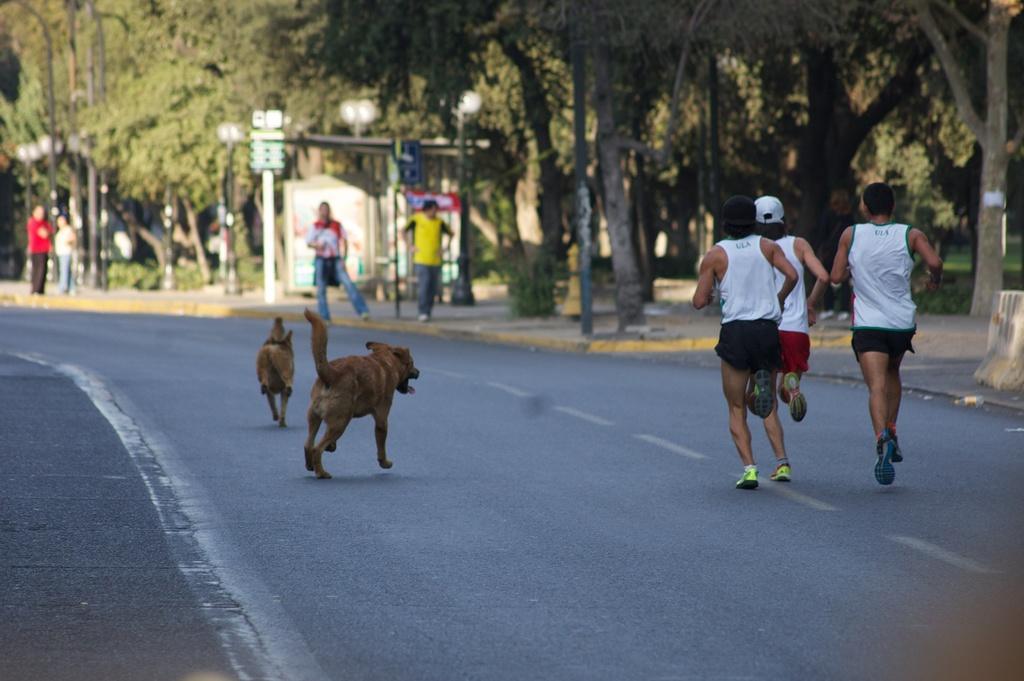Please provide a concise description of this image. This image consists of many people. On the right, there are three men running on the road. On the left, there are two dogs running on the road. At the bottom, there is a road. In the background, we can see many trees. And there are four persons standing on the pavement. In the middle, there is a small cabin. 